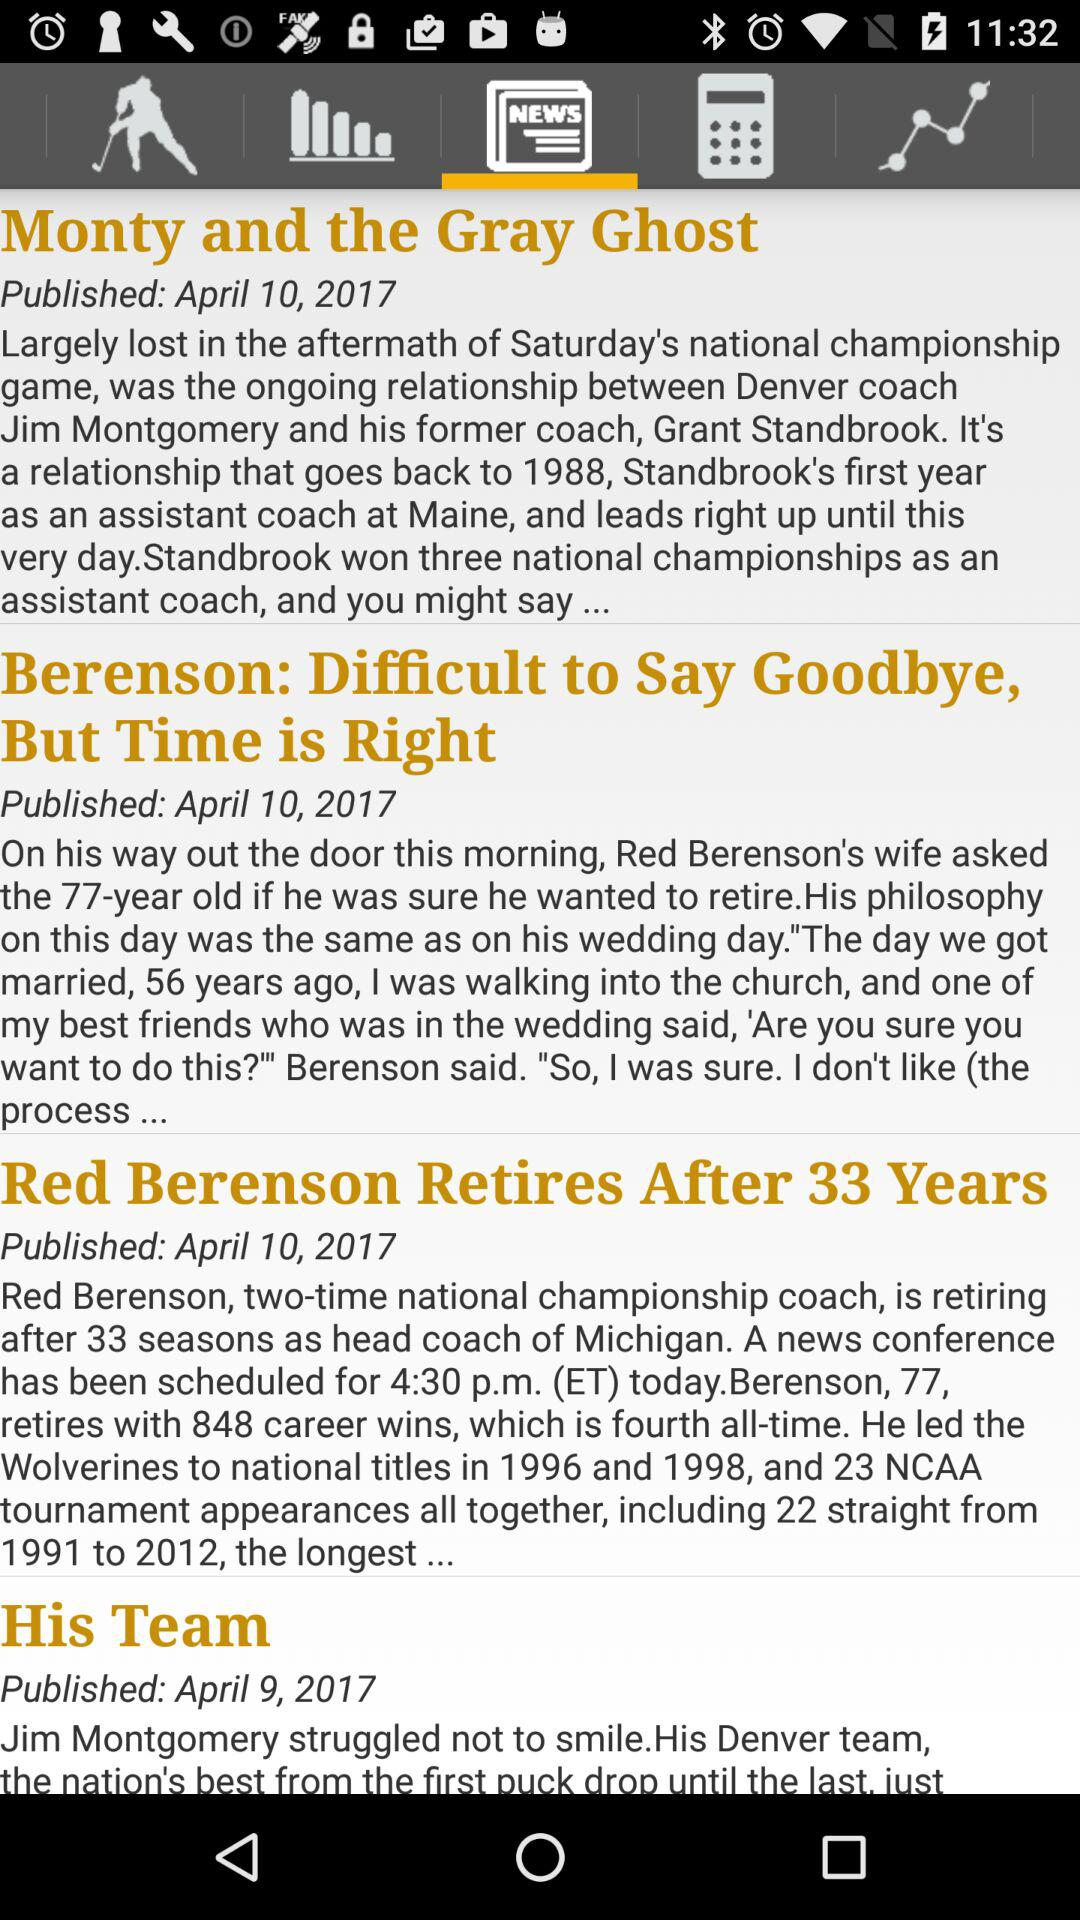What is the publication date of the article "Monty and the Gray Ghost"? The publication date of the article "Monty and the Gray Ghost" is April 10, 2017. 